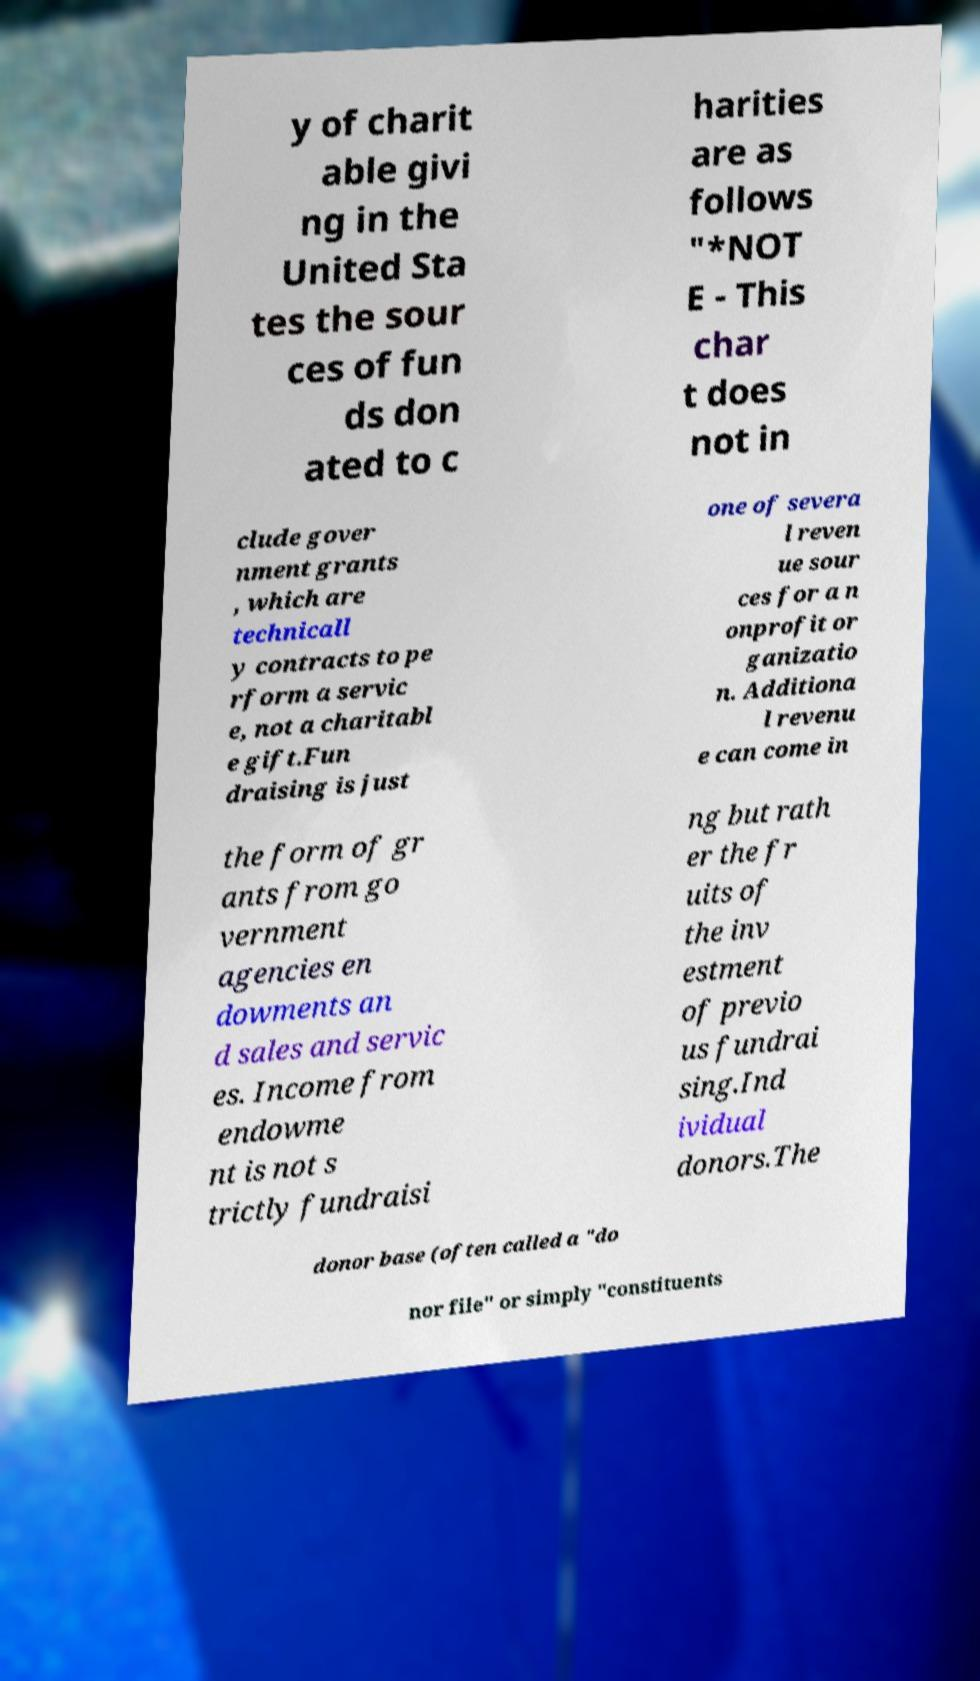Could you assist in decoding the text presented in this image and type it out clearly? y of charit able givi ng in the United Sta tes the sour ces of fun ds don ated to c harities are as follows "*NOT E - This char t does not in clude gover nment grants , which are technicall y contracts to pe rform a servic e, not a charitabl e gift.Fun draising is just one of severa l reven ue sour ces for a n onprofit or ganizatio n. Additiona l revenu e can come in the form of gr ants from go vernment agencies en dowments an d sales and servic es. Income from endowme nt is not s trictly fundraisi ng but rath er the fr uits of the inv estment of previo us fundrai sing.Ind ividual donors.The donor base (often called a "do nor file" or simply "constituents 